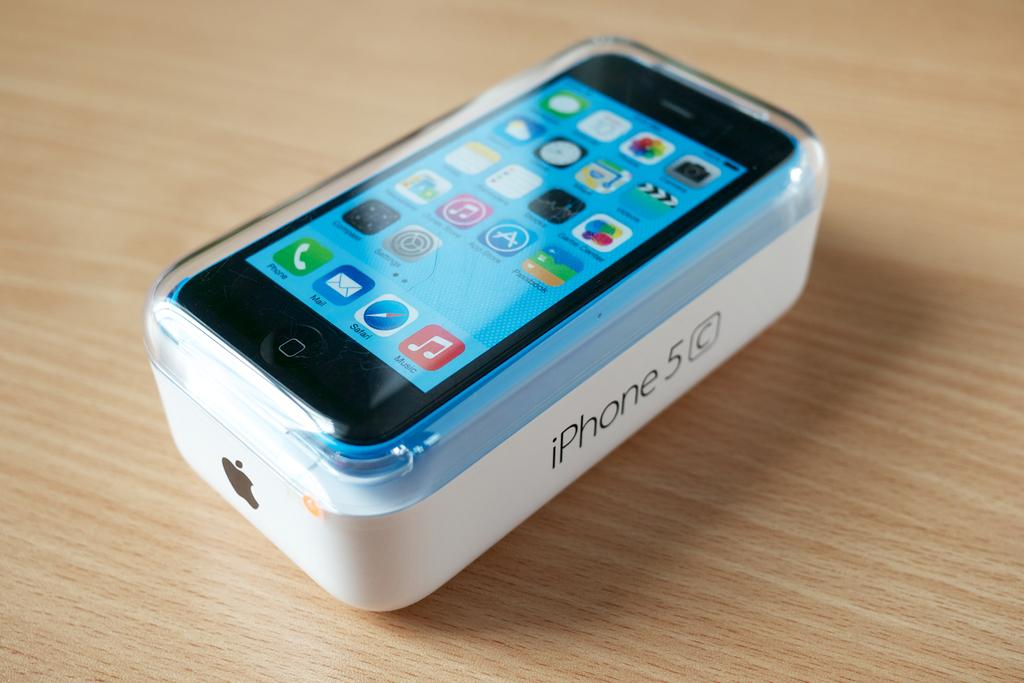<image>
Offer a succinct explanation of the picture presented. A new Iphone in a case is sitting on an Iphone box labeled iphone 5c. 